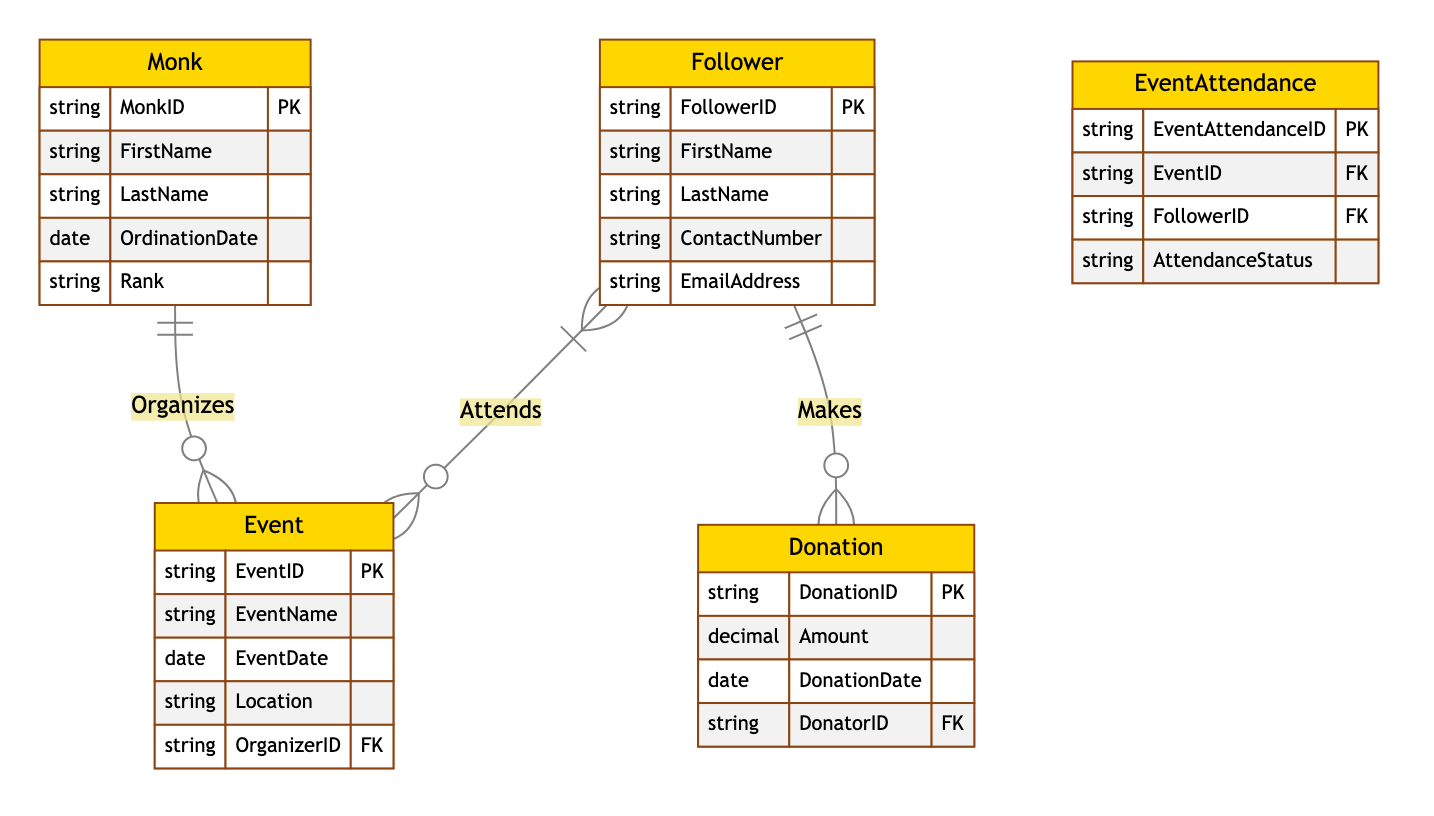What is the primary key of the Monk entity? The primary key of the Monk entity is identified as MonkID. This is an attribute listed within the Monk entity and labeled as the Primary Key.
Answer: MonkID How many entities are there in the diagram? The diagram includes five entities: Monk, Follower, Event, Donation, and EventAttendance. Counting each unique entity gives the total.
Answer: Five What relationship exists between Monk and Event? The relationship between Monk and Event is defined as "Organizes." This relationship is represented by a one-to-many connection, indicating a Monk can organize many Events.
Answer: Organizes Which entity links Follower and Event through attendance? The linking entity is EventAttendance. It showcases the relationship between Followers attending Events and is necessary for establishing the attendance status.
Answer: EventAttendance How many donations can a single Follower make? A single Follower can make multiple donations as indicated by the one-to-many relationship between Follower and Donation, allowing multiple donations associated with one Follower.
Answer: Many What does the AttendanceStatus attribute represent? The AttendanceStatus attribute represents the attendance condition of a Follower for a particular Event. It provides information regarding whether the Follower attended, missed, or is planning to attend the Event.
Answer: AttendanceStatus Which entity is responsible for organizing Events? The Monk entity is responsible for organizing Events as indicated by the relationship labeled "Organizes." This shows that each Event is linked to one Monk who organizes it.
Answer: Monk What is the foreign key in the Event entity? The foreign key in the Event entity is OrganizerID. This attribute refers to the Monk organizing the event and links to the Monk entity.
Answer: OrganizerID Can a single Event have multiple Followers attending? Yes, a single Event can have multiple Followers attending. The many-to-many relationship between Follower and Event, facilitated by EventAttendance, allows numerous Followers to attend the same Event.
Answer: Yes 